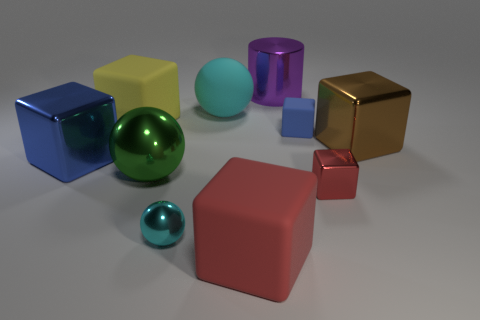Subtract 3 blocks. How many blocks are left? 3 Subtract all large red cubes. How many cubes are left? 5 Subtract all brown cubes. How many cubes are left? 5 Subtract all brown cubes. Subtract all yellow cylinders. How many cubes are left? 5 Subtract all cylinders. How many objects are left? 9 Subtract all tiny blue matte cubes. Subtract all purple objects. How many objects are left? 8 Add 9 green objects. How many green objects are left? 10 Add 7 cyan spheres. How many cyan spheres exist? 9 Subtract 0 green blocks. How many objects are left? 10 